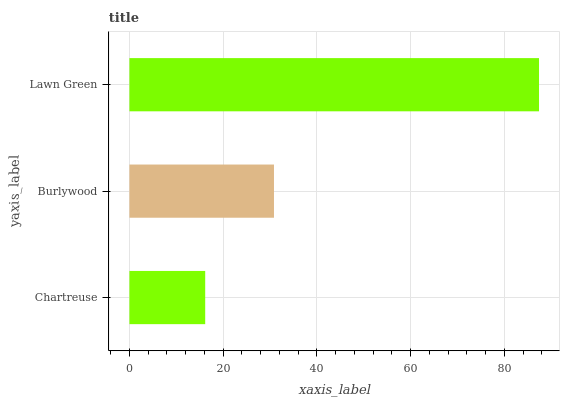Is Chartreuse the minimum?
Answer yes or no. Yes. Is Lawn Green the maximum?
Answer yes or no. Yes. Is Burlywood the minimum?
Answer yes or no. No. Is Burlywood the maximum?
Answer yes or no. No. Is Burlywood greater than Chartreuse?
Answer yes or no. Yes. Is Chartreuse less than Burlywood?
Answer yes or no. Yes. Is Chartreuse greater than Burlywood?
Answer yes or no. No. Is Burlywood less than Chartreuse?
Answer yes or no. No. Is Burlywood the high median?
Answer yes or no. Yes. Is Burlywood the low median?
Answer yes or no. Yes. Is Chartreuse the high median?
Answer yes or no. No. Is Chartreuse the low median?
Answer yes or no. No. 